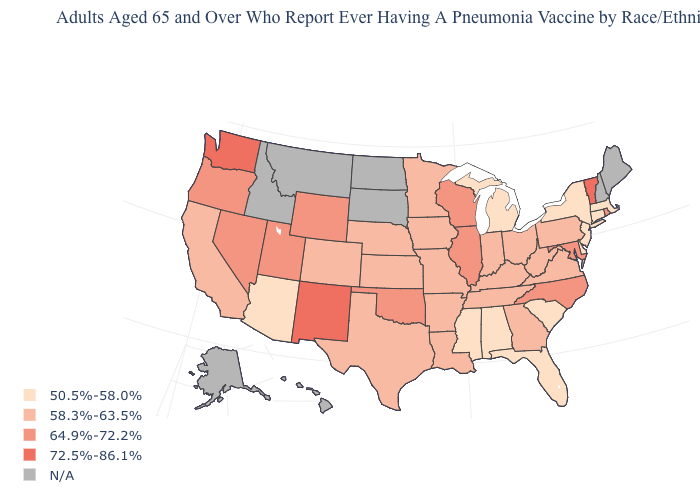Is the legend a continuous bar?
Be succinct. No. Name the states that have a value in the range 58.3%-63.5%?
Be succinct. Arkansas, California, Colorado, Georgia, Indiana, Iowa, Kansas, Kentucky, Louisiana, Minnesota, Missouri, Nebraska, Ohio, Pennsylvania, Tennessee, Texas, Virginia, West Virginia. Name the states that have a value in the range 50.5%-58.0%?
Short answer required. Alabama, Arizona, Connecticut, Delaware, Florida, Massachusetts, Michigan, Mississippi, New Jersey, New York, South Carolina. What is the value of Virginia?
Quick response, please. 58.3%-63.5%. What is the lowest value in the West?
Write a very short answer. 50.5%-58.0%. Which states hav the highest value in the MidWest?
Be succinct. Illinois, Wisconsin. What is the value of Hawaii?
Keep it brief. N/A. Does the first symbol in the legend represent the smallest category?
Give a very brief answer. Yes. What is the lowest value in the West?
Keep it brief. 50.5%-58.0%. Is the legend a continuous bar?
Give a very brief answer. No. What is the highest value in the South ?
Concise answer only. 64.9%-72.2%. What is the lowest value in the USA?
Short answer required. 50.5%-58.0%. Name the states that have a value in the range 72.5%-86.1%?
Answer briefly. New Mexico, Vermont, Washington. Does North Carolina have the highest value in the USA?
Keep it brief. No. 